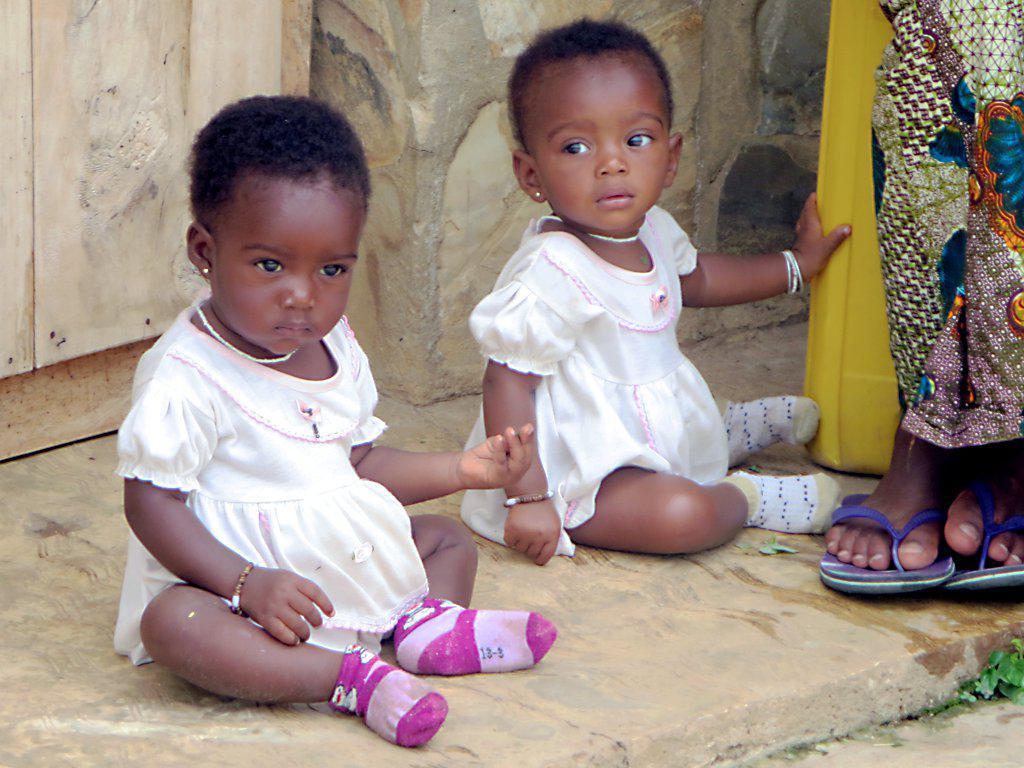In one or two sentences, can you explain what this image depicts? In this picture we can see two kids sitting, in the background there is a wall, on the right side we can see another person, at the right bottom there is a plant. 